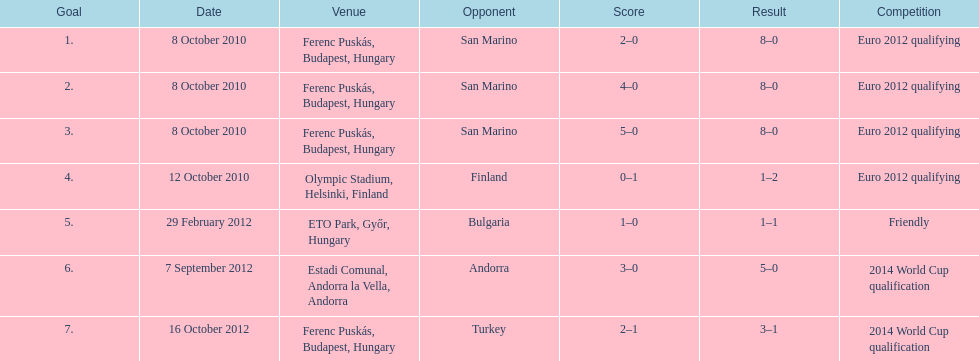Szalai tallied all but one of his international goals in either euro 2012 qualifying or what other phase of play? 2014 World Cup qualification. 